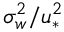<formula> <loc_0><loc_0><loc_500><loc_500>\sigma _ { w } ^ { 2 } / u _ { * } ^ { 2 }</formula> 